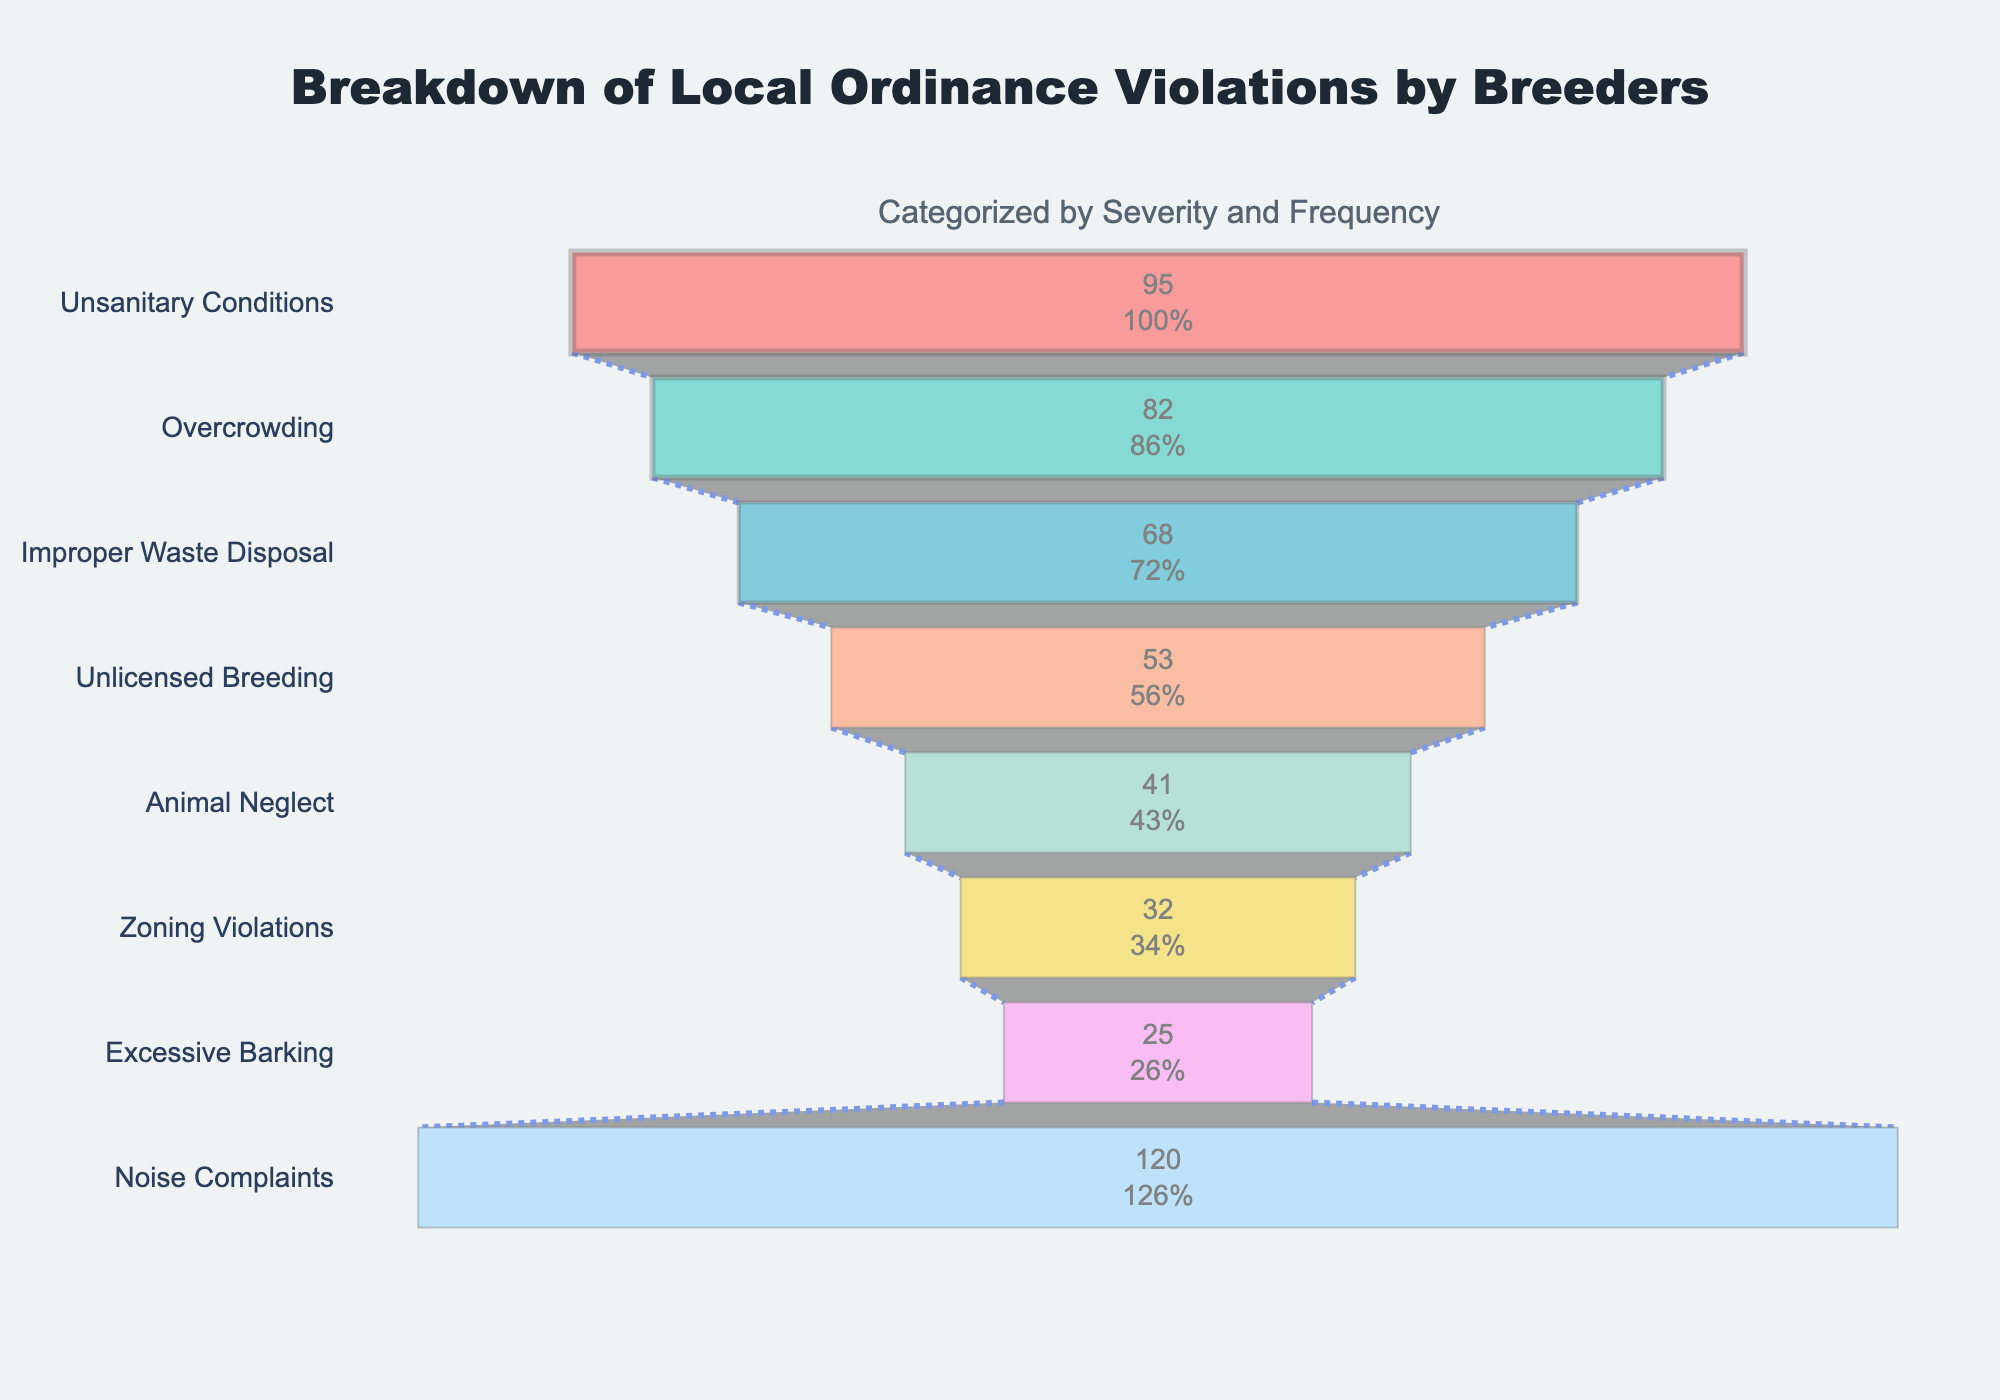What's the most frequent type of violation according to the chart? The most frequent type of violation can be identified by looking at the top section of the funnel chart, which represents the highest number of violations. "Noise Complaints" is at the top.
Answer: Noise Complaints How many categories are displayed in the chart? To determine the number of categories, count the distinct sections in the funnel chart. The chart displays 8 sections.
Answer: 8 Which category has the smallest number of violations? The smallest number of violations is at the bottom section of the funnel chart. "Excessive Barking" has the fewest violations.
Answer: Excessive Barking What's the difference in the number of violations between 'Noise Complaints' and 'Animal Neglect'? First, find the number of violations for both categories: 120 for Noise Complaints and 41 for Animal Neglect. Subtract the smaller number from the larger one (120 - 41).
Answer: 79 Which categories have a frequency that exceeds 50%? Reviewing the frequencies, any category with a frequency percentage above 50% qualifies. The categories are "Noise Complaints," "Unsanitary Conditions," "Overcrowding," and "Improper Waste Disposal."
Answer: Noise Complaints, Unsanitary Conditions, Overcrowding, Improper Waste Disposal What percentage of violations do 'Unlicensed Breeding' and 'Animal Neglect' together represent? Sum the violations for both categories: 53 (Unlicensed Breeding) and 41 (Animal Neglect), making a total of 94. To find the percentage, one would need the total number of violations across all categories and calculate. Total violations are 516. (94 / 516) * 100 ≈ 18.22%.
Answer: 18.22% Which category is positioned exactly in the middle of the funnel chart? The middle position can be found by counting the sections. The 4th section from the top in an 8-section chart is the middle one. "Improper Waste Disposal" lies in this position.
Answer: Improper Waste Disposal How many violations are there in total for all categories combined? Sum the number of violations for all the categories displayed in the chart: 120 (Noise Complaints) + 95 (Unsanitary Conditions) + 82 (Overcrowding) + 68 (Improper Waste Disposal) + 53 (Unlicensed Breeding) + 41 (Animal Neglect) + 32 (Zoning Violations) + 25 (Excessive Barking). The total is 516.
Answer: 516 Which two categories have almost the same number of violations, and what is the difference between them? Compare the numbers to find close values. "Improper Waste Disposal" (68) and "Unlicensed Breeding" (53). The difference is (68 - 53) = 15.
Answer: Improper Waste Disposal, Unlicensed Breeding, 15 